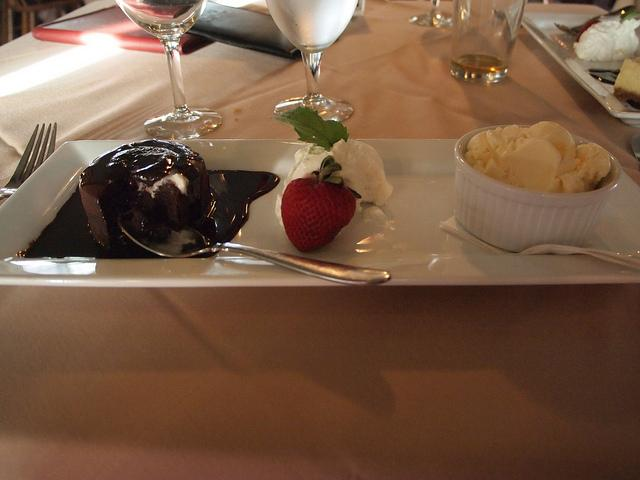What color is the chocolate on top of the white plate? Please explain your reasoning. black. Chocolate has some milk added to it which gives it a brown consistency rather than black. 